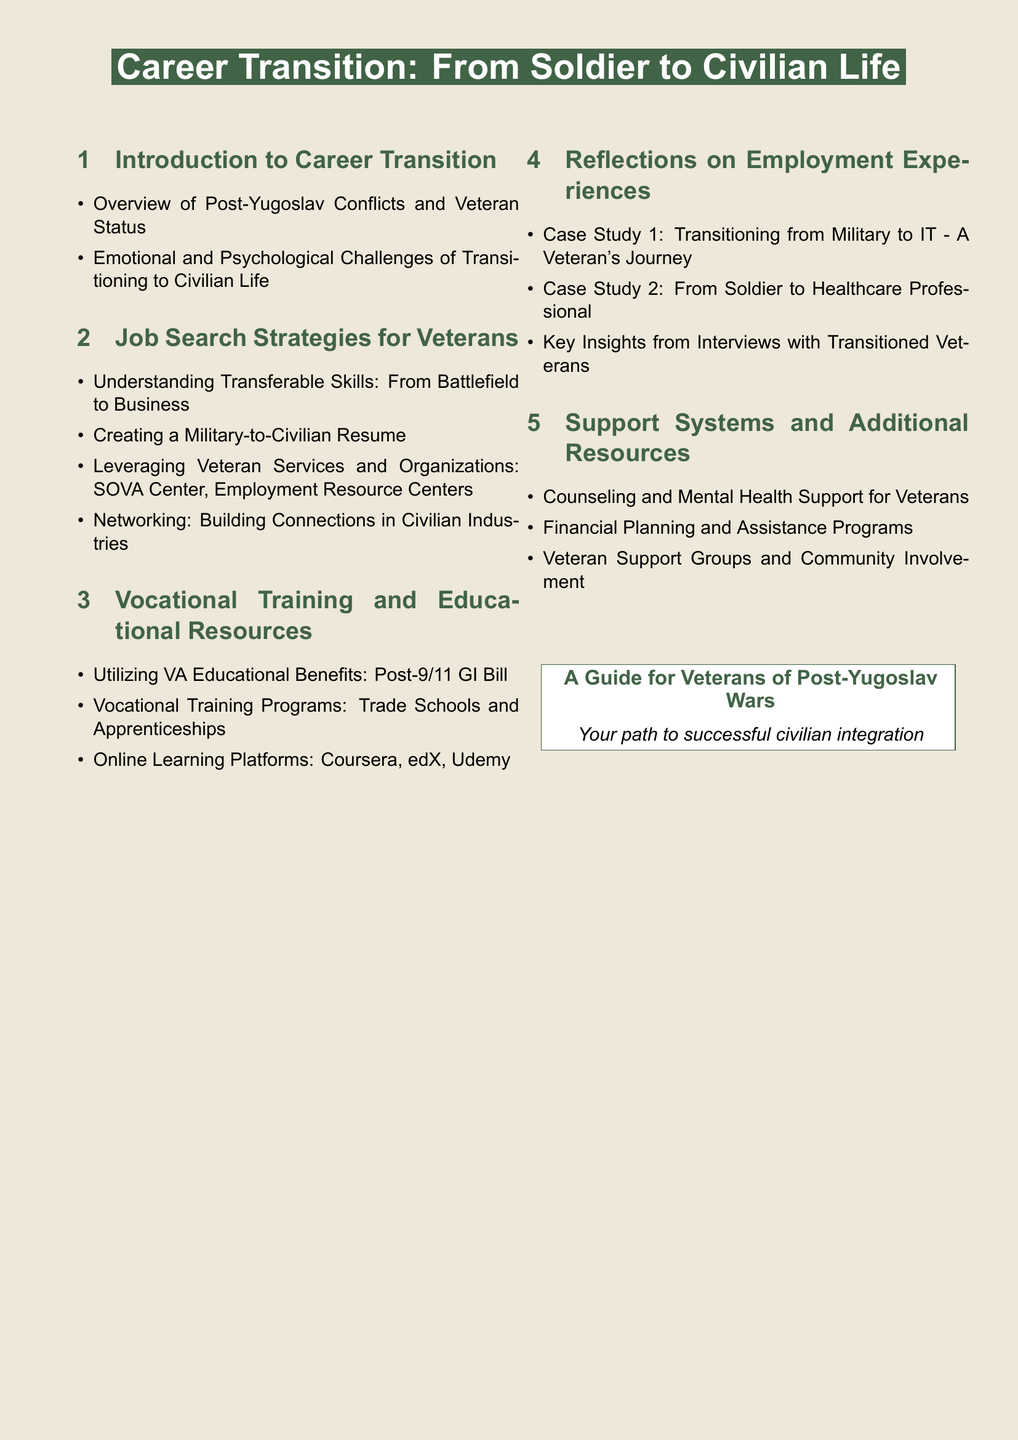what is the title of the document? The title of the document is prominently displayed on the cover page.
Answer: Career Transition: From Soldier to Civilian Life how many sections are in the document? The document's structure includes a specific number of sections listed in the table of contents.
Answer: Five sections what is discussed in the first section? The first section provides insights into the challenges and context of transitioning to civilian life for veterans.
Answer: Introduction to Career Transition which educational benefit is mentioned? The document lists specific educational benefits available to veterans in the vocational training section.
Answer: Post-9/11 GI Bill what supports are highlighted in the last section? The last section contains information on different types of support available for veterans after military service.
Answer: Counseling and Mental Health Support which case study focuses on the IT field? The reflections section includes various case studies that detail different career paths taken by veterans.
Answer: Case Study 1: Transitioning from Military to IT how many case studies are provided in the reflections section? The number of case studies listed in the document section reflects different veteran experiences in transitioning careers.
Answer: Two case studies what is one resource for online learning mentioned? The document provides examples of platforms that offer educational resources for veterans.
Answer: Coursera who provides networking opportunities for veterans? The document suggests organizations that assist veterans in building professional connections for job searches.
Answer: Veteran Services and Organizations 